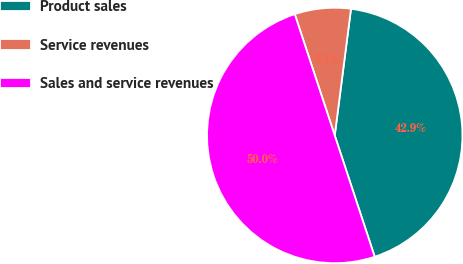<chart> <loc_0><loc_0><loc_500><loc_500><pie_chart><fcel>Product sales<fcel>Service revenues<fcel>Sales and service revenues<nl><fcel>42.9%<fcel>7.1%<fcel>50.0%<nl></chart> 